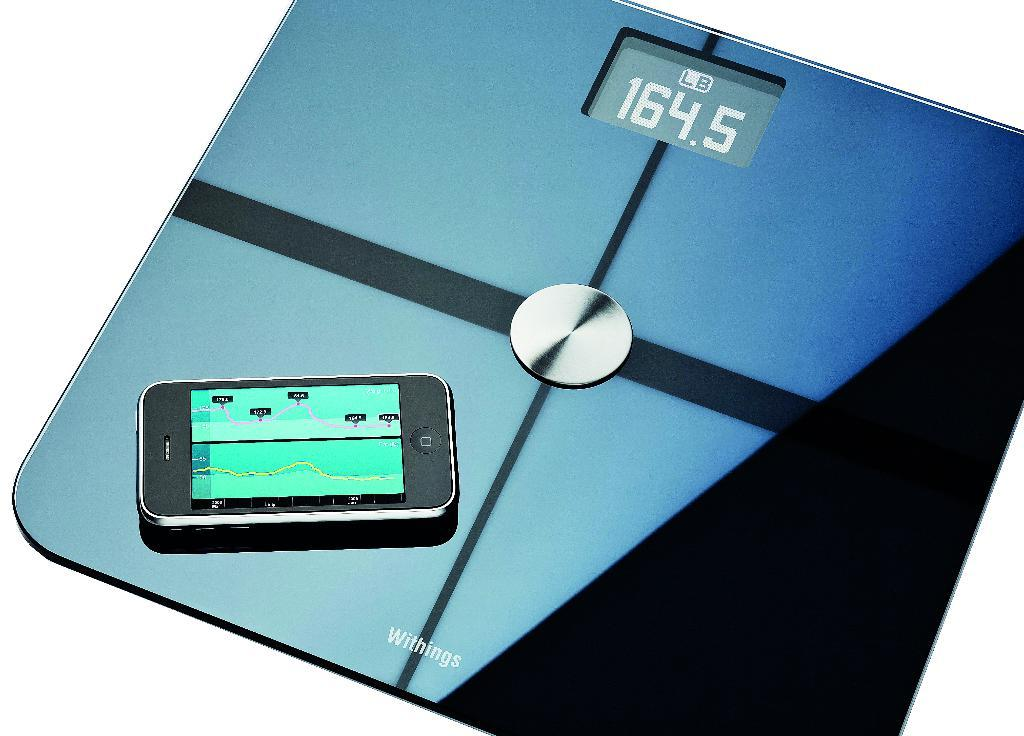<image>
Create a compact narrative representing the image presented. Phone on top of a black scale that says 164.5 on the screen. 